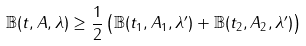<formula> <loc_0><loc_0><loc_500><loc_500>\mathbb { B } ( t , A , \lambda ) \geq \frac { 1 } { 2 } \left ( \mathbb { B } ( t _ { 1 } , A _ { 1 } , \lambda ^ { \prime } ) + \mathbb { B } ( t _ { 2 } , A _ { 2 } , \lambda ^ { \prime } ) \right )</formula> 